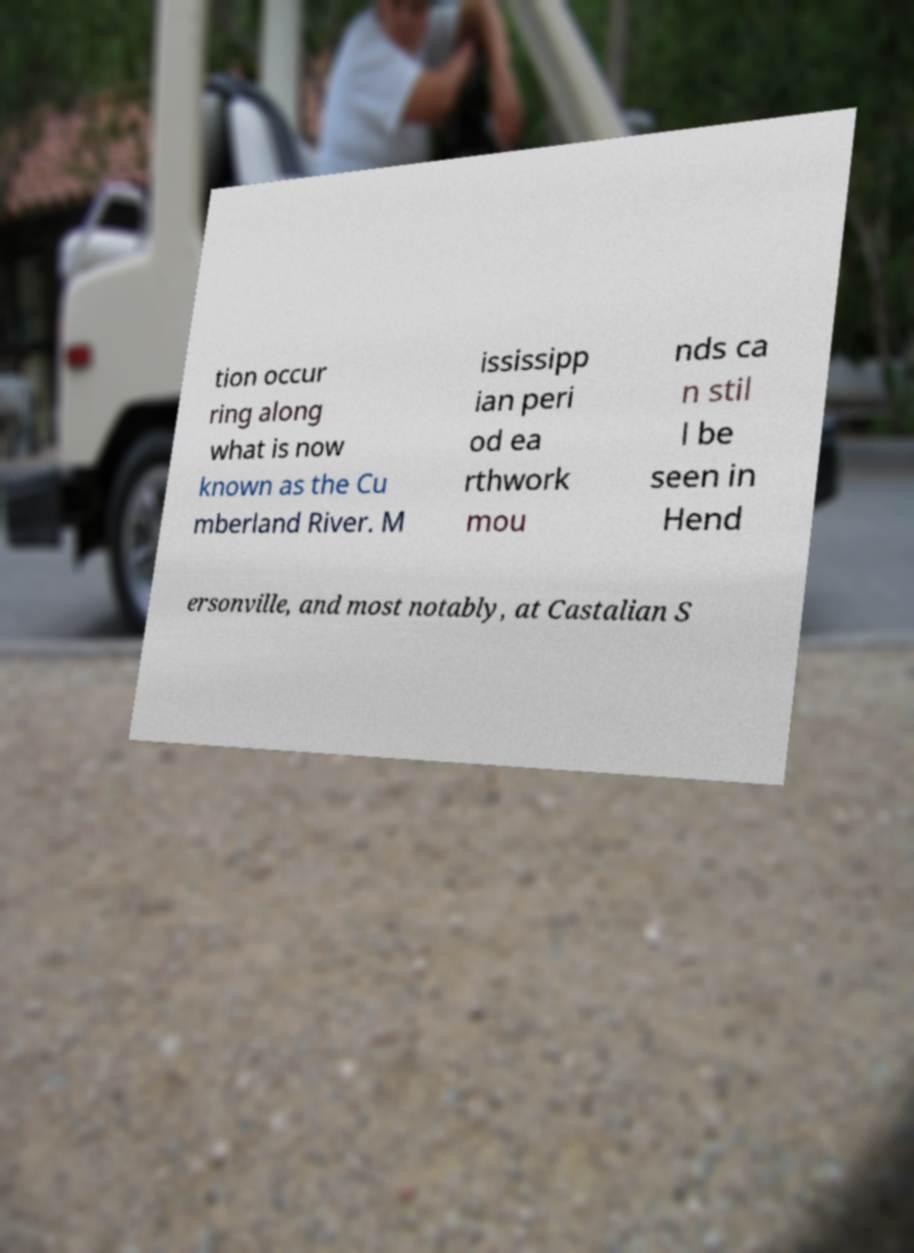Could you assist in decoding the text presented in this image and type it out clearly? tion occur ring along what is now known as the Cu mberland River. M ississipp ian peri od ea rthwork mou nds ca n stil l be seen in Hend ersonville, and most notably, at Castalian S 